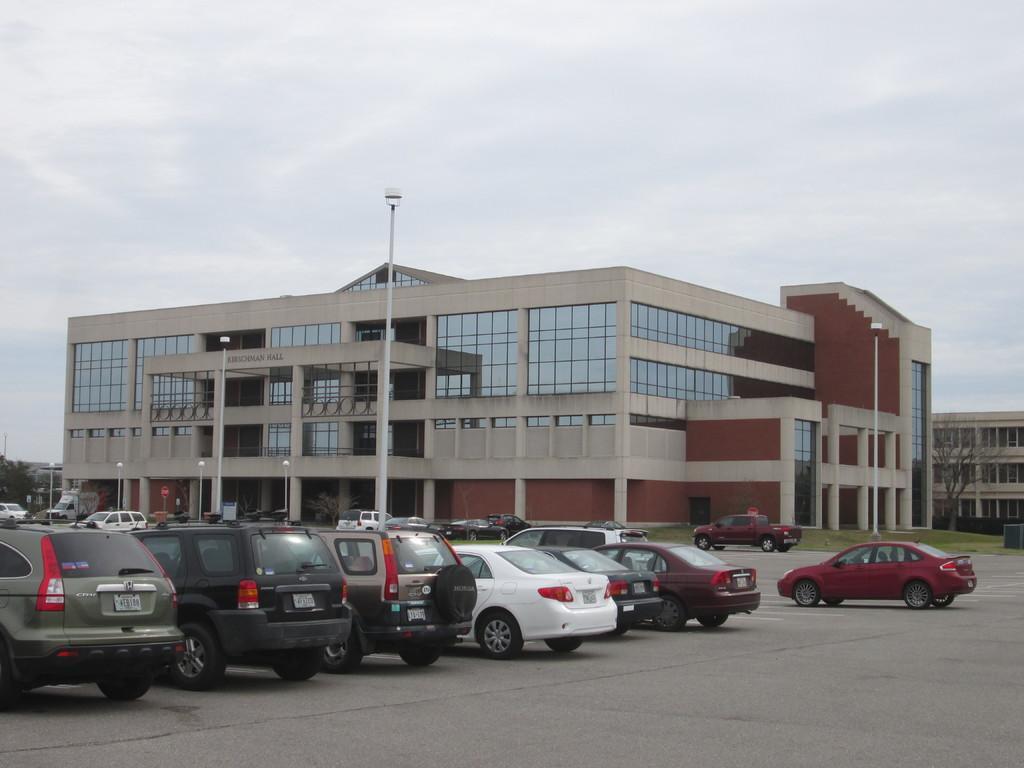Please provide a concise description of this image. In this picture we can see few vehicles on the path. There are some lights on the path. We can see few trees and buildings in the background. Sky is cloudy. 